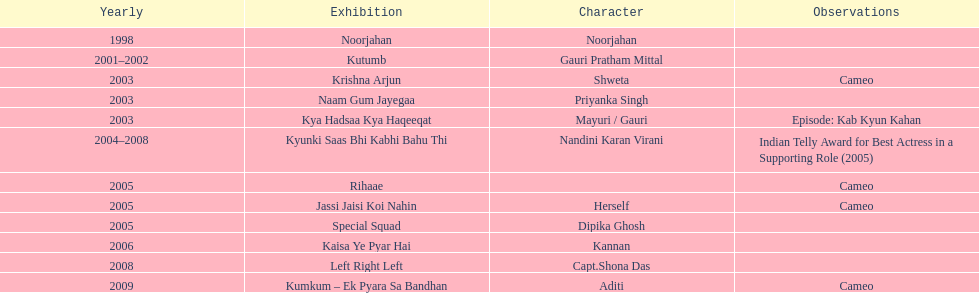What was the most years a show lasted? 4. 